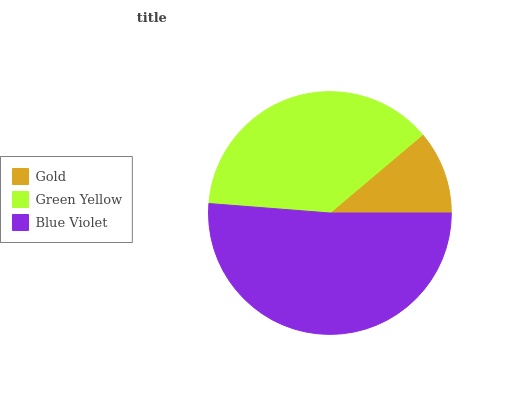Is Gold the minimum?
Answer yes or no. Yes. Is Blue Violet the maximum?
Answer yes or no. Yes. Is Green Yellow the minimum?
Answer yes or no. No. Is Green Yellow the maximum?
Answer yes or no. No. Is Green Yellow greater than Gold?
Answer yes or no. Yes. Is Gold less than Green Yellow?
Answer yes or no. Yes. Is Gold greater than Green Yellow?
Answer yes or no. No. Is Green Yellow less than Gold?
Answer yes or no. No. Is Green Yellow the high median?
Answer yes or no. Yes. Is Green Yellow the low median?
Answer yes or no. Yes. Is Blue Violet the high median?
Answer yes or no. No. Is Blue Violet the low median?
Answer yes or no. No. 